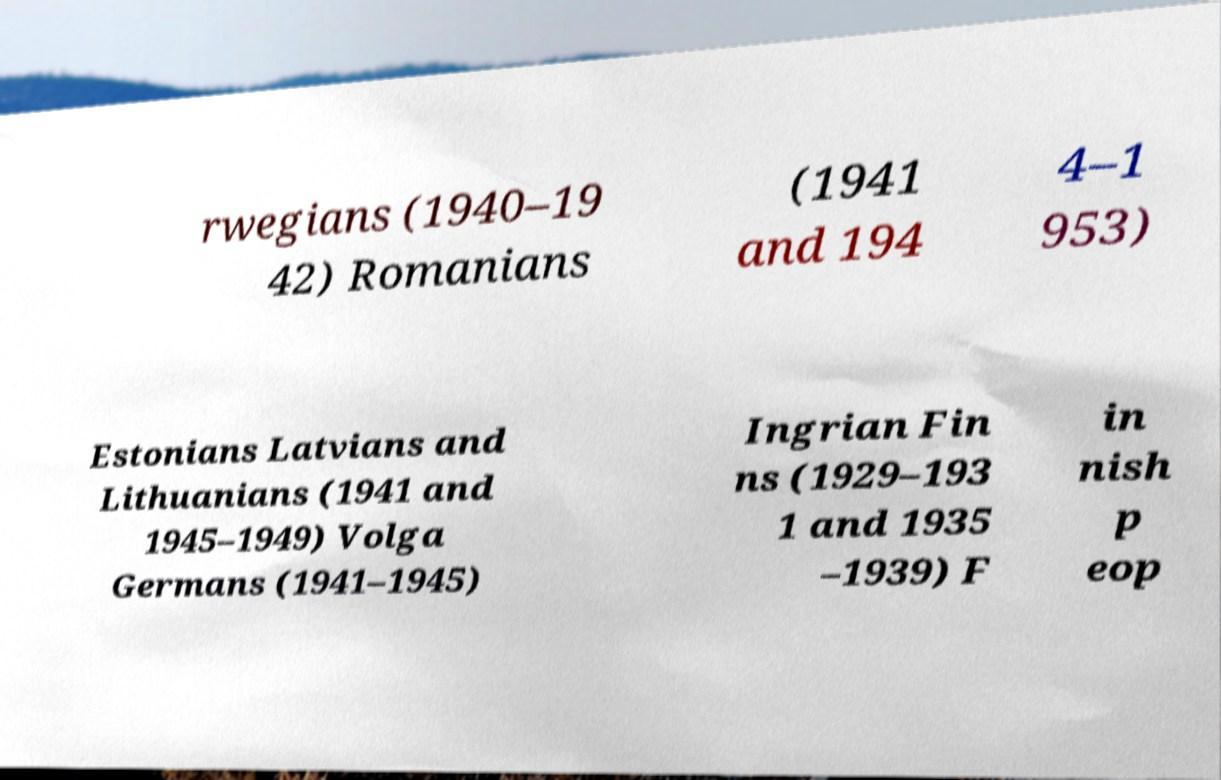I need the written content from this picture converted into text. Can you do that? rwegians (1940–19 42) Romanians (1941 and 194 4–1 953) Estonians Latvians and Lithuanians (1941 and 1945–1949) Volga Germans (1941–1945) Ingrian Fin ns (1929–193 1 and 1935 –1939) F in nish p eop 